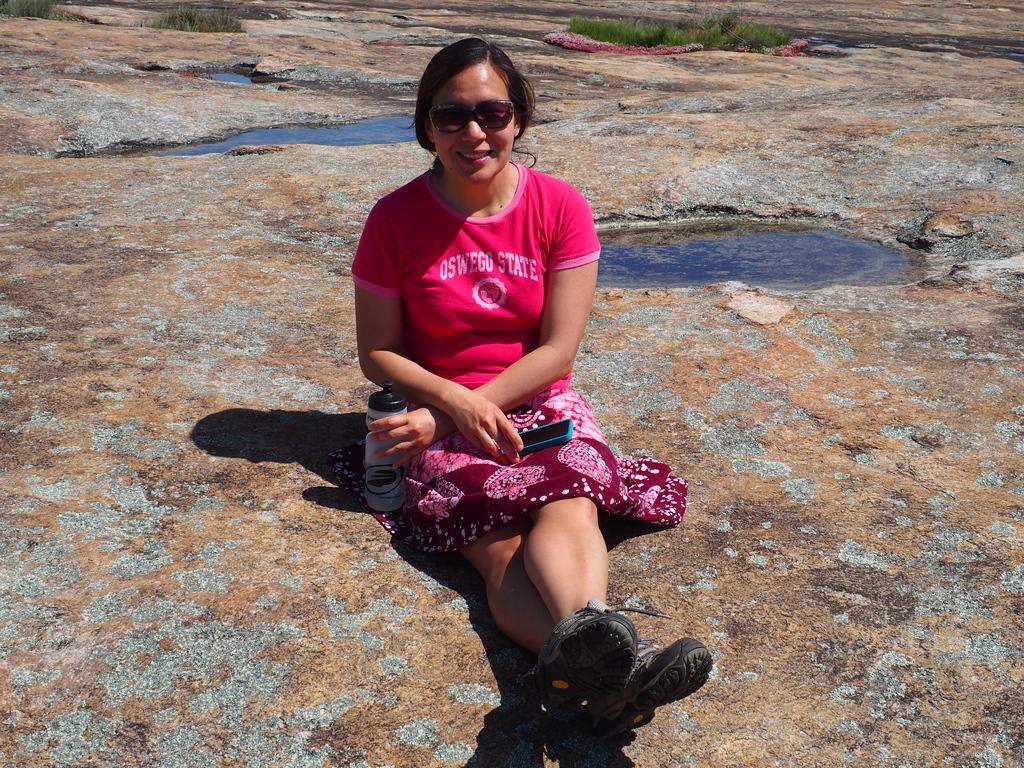In one or two sentences, can you explain what this image depicts? In this picture we can see a woman is sitting and she is holding a bottle and a mobile. Behind the woman, there is water and grass. 